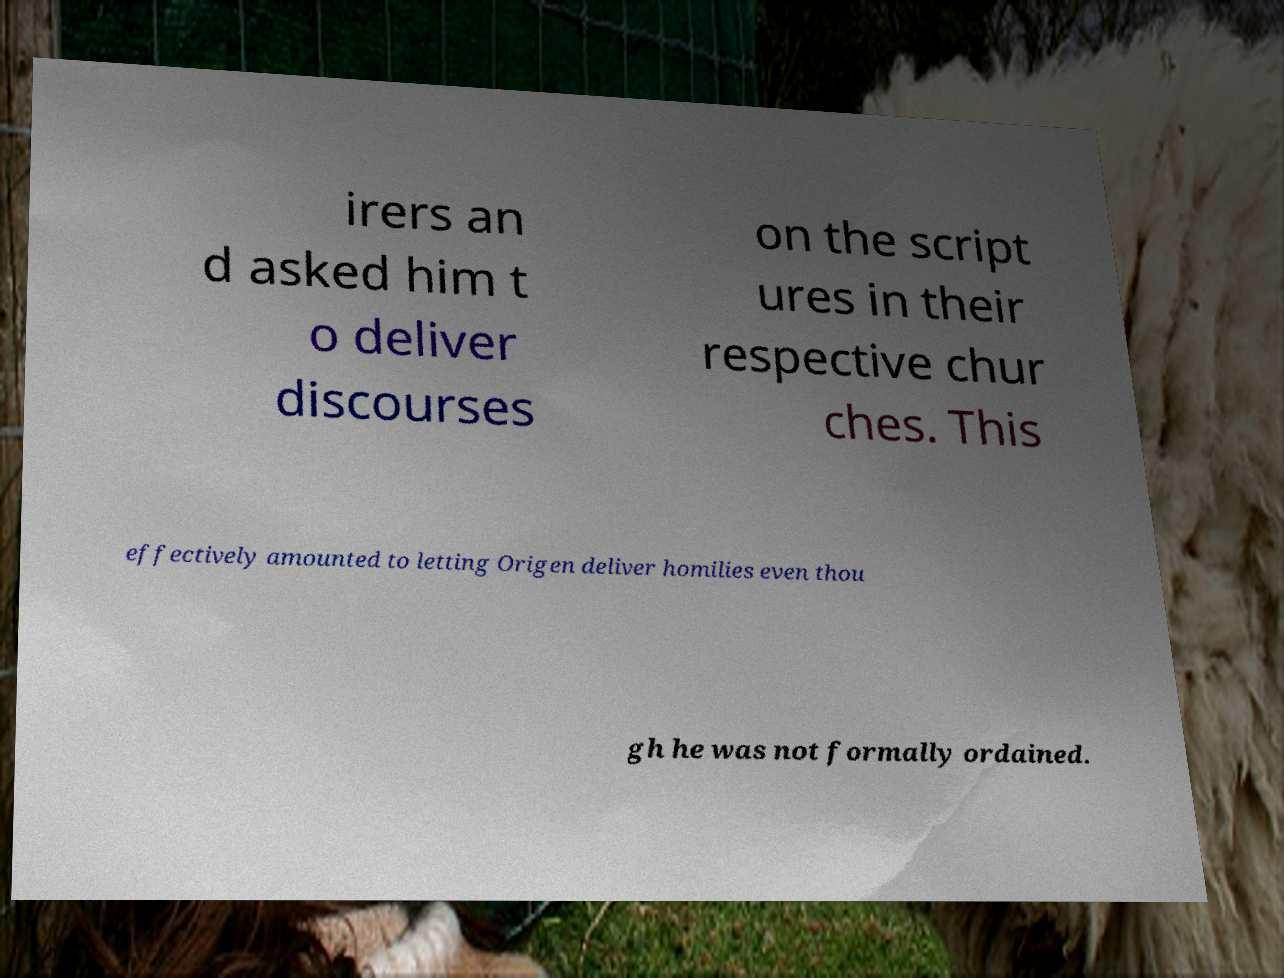Please identify and transcribe the text found in this image. irers an d asked him t o deliver discourses on the script ures in their respective chur ches. This effectively amounted to letting Origen deliver homilies even thou gh he was not formally ordained. 